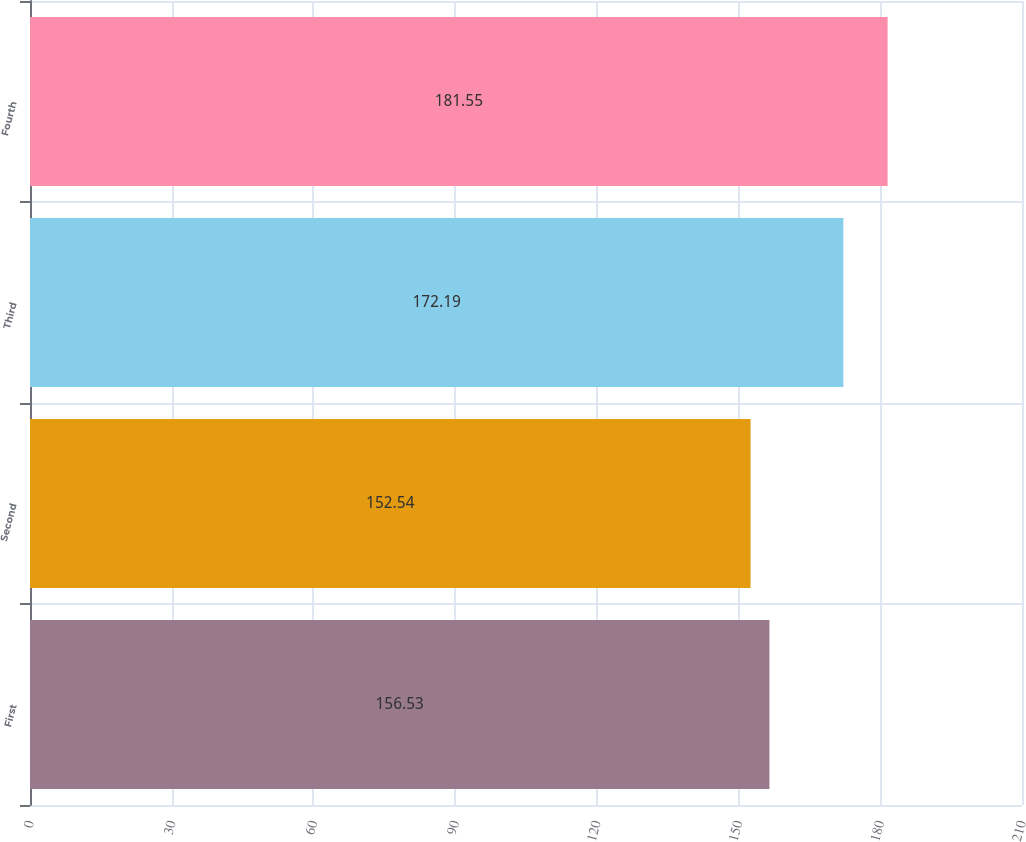Convert chart. <chart><loc_0><loc_0><loc_500><loc_500><bar_chart><fcel>First<fcel>Second<fcel>Third<fcel>Fourth<nl><fcel>156.53<fcel>152.54<fcel>172.19<fcel>181.55<nl></chart> 